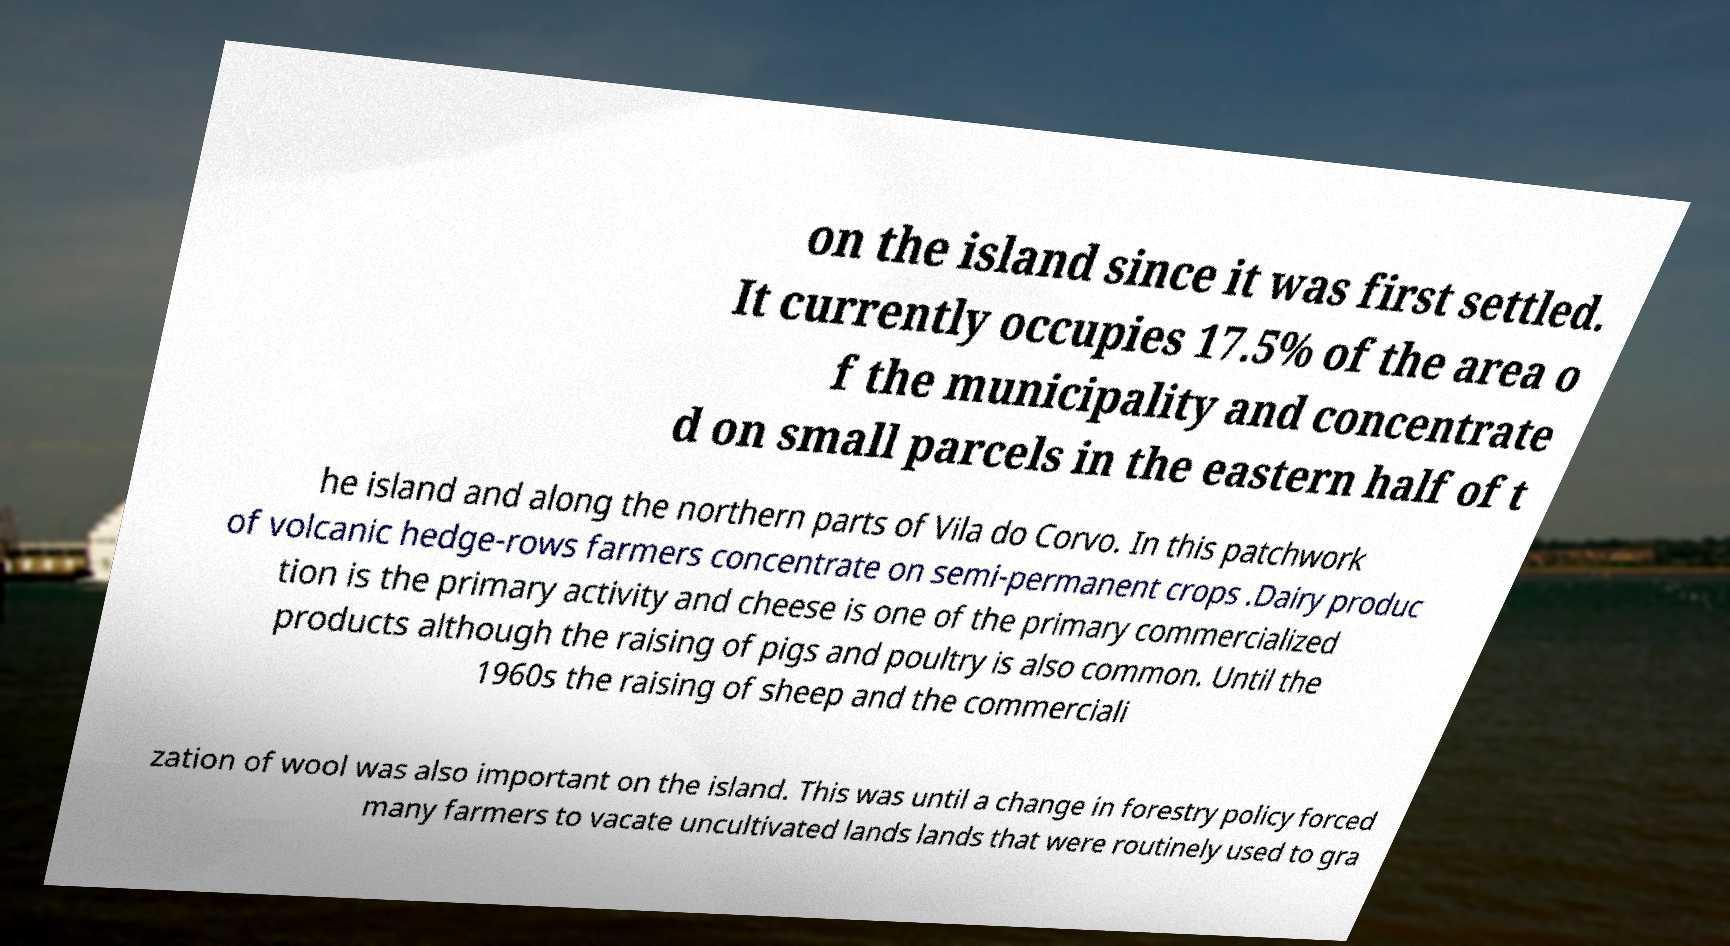What messages or text are displayed in this image? I need them in a readable, typed format. on the island since it was first settled. It currently occupies 17.5% of the area o f the municipality and concentrate d on small parcels in the eastern half of t he island and along the northern parts of Vila do Corvo. In this patchwork of volcanic hedge-rows farmers concentrate on semi-permanent crops .Dairy produc tion is the primary activity and cheese is one of the primary commercialized products although the raising of pigs and poultry is also common. Until the 1960s the raising of sheep and the commerciali zation of wool was also important on the island. This was until a change in forestry policy forced many farmers to vacate uncultivated lands lands that were routinely used to gra 